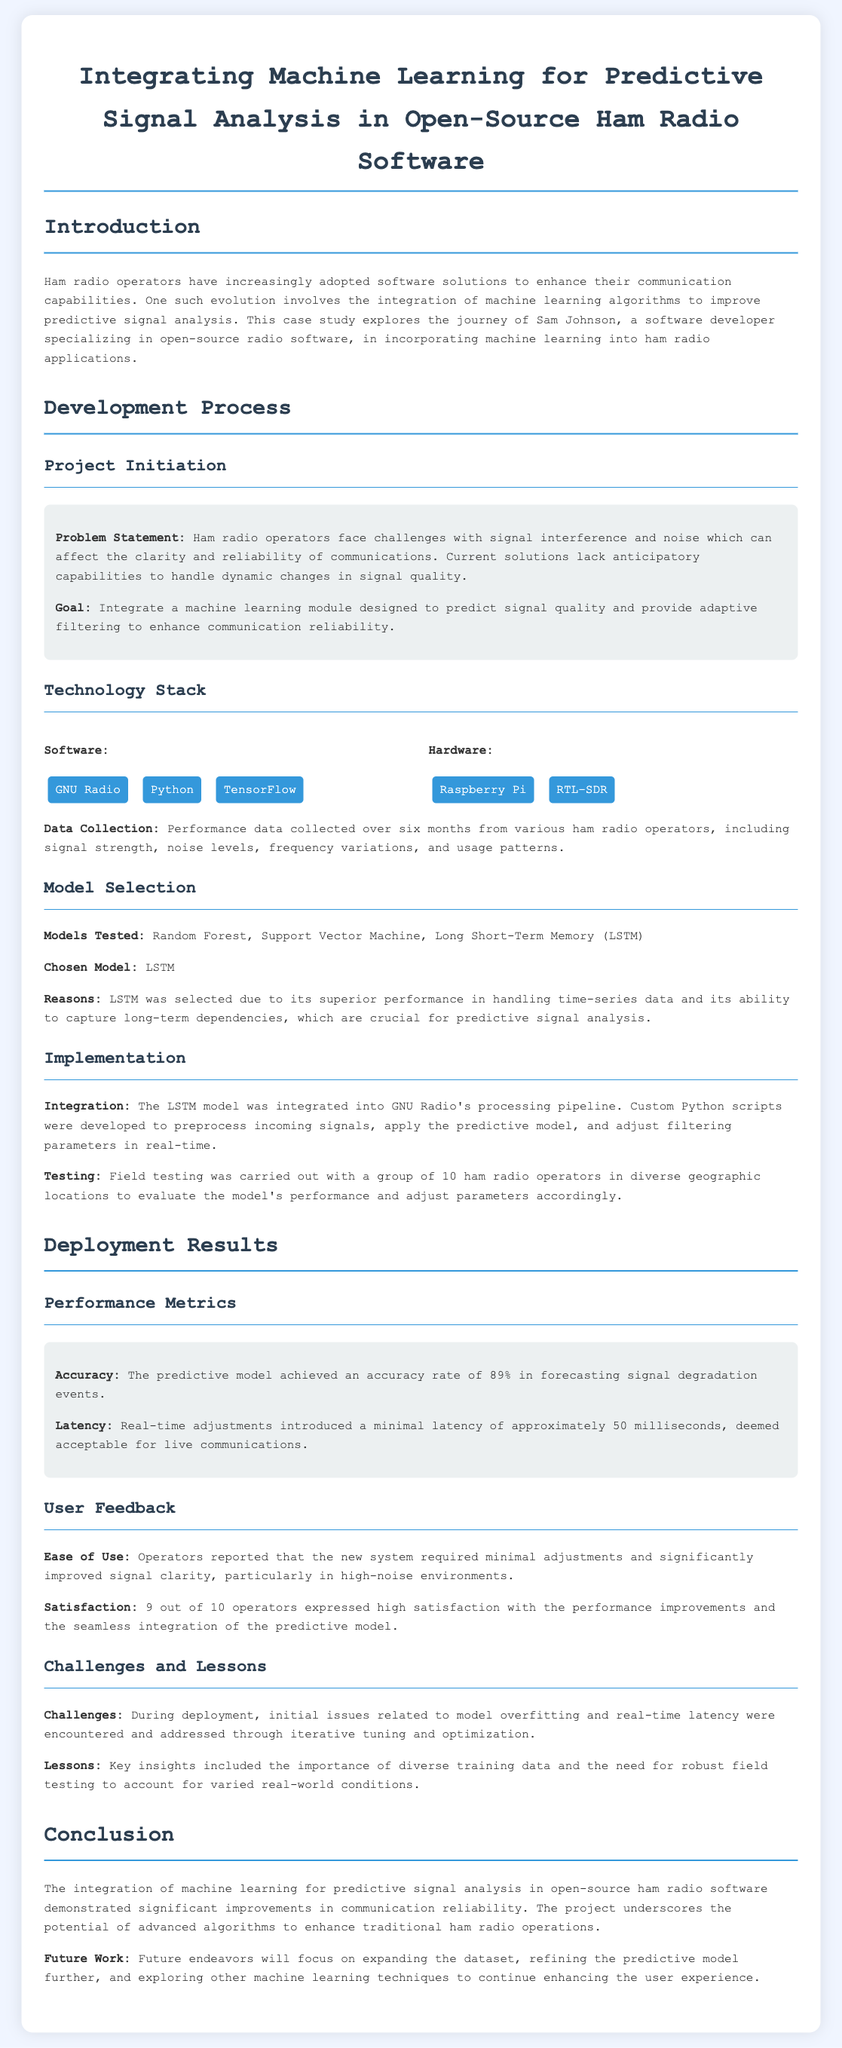what is the accuracy achieved by the predictive model? The document mentions that the predictive model achieved an accuracy rate of 89% in forecasting signal degradation events.
Answer: 89% what technology stack was used for the project? The document lists the software and hardware used in the project, including GNU Radio, Python, TensorFlow, Raspberry Pi, and RTL-SDR.
Answer: GNU Radio, Python, TensorFlow, Raspberry Pi, RTL-SDR which machine learning model was chosen for this project? The report indicates that Long Short-Term Memory (LSTM) was selected as the model for predictive signal analysis due to its performance.
Answer: LSTM how many ham radio operators participated in the field testing? The case study states that field testing was carried out with a group of 10 ham radio operators.
Answer: 10 what is one of the challenges faced during deployment? The document mentions initial issues related to model overfitting as one of the challenges encountered during deployment.
Answer: model overfitting what was the user satisfaction rate reported by operators? It is noted that 9 out of 10 operators expressed high satisfaction with the new predictive model's performance.
Answer: 9 out of 10 what future work is proposed in the project? The document outlines that future endeavors will focus on expanding the dataset, refining the predictive model, and exploring other techniques.
Answer: expanding the dataset, refining the model what was the latency introduced by real-time adjustments? The document states that the real-time adjustments introduced a minimal latency of approximately 50 milliseconds.
Answer: 50 milliseconds 